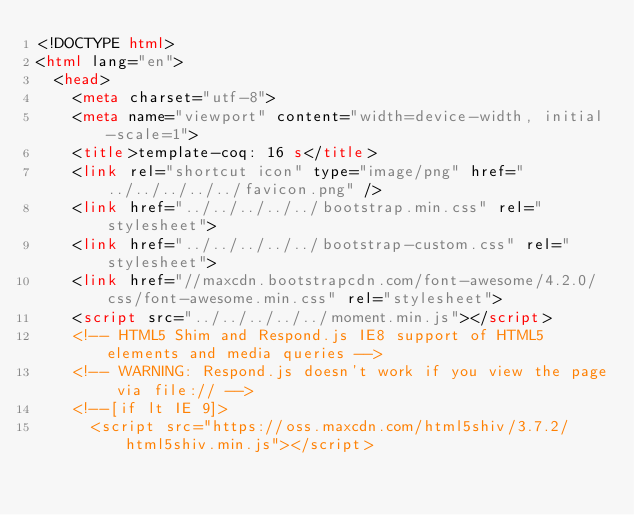Convert code to text. <code><loc_0><loc_0><loc_500><loc_500><_HTML_><!DOCTYPE html>
<html lang="en">
  <head>
    <meta charset="utf-8">
    <meta name="viewport" content="width=device-width, initial-scale=1">
    <title>template-coq: 16 s</title>
    <link rel="shortcut icon" type="image/png" href="../../../../../favicon.png" />
    <link href="../../../../../bootstrap.min.css" rel="stylesheet">
    <link href="../../../../../bootstrap-custom.css" rel="stylesheet">
    <link href="//maxcdn.bootstrapcdn.com/font-awesome/4.2.0/css/font-awesome.min.css" rel="stylesheet">
    <script src="../../../../../moment.min.js"></script>
    <!-- HTML5 Shim and Respond.js IE8 support of HTML5 elements and media queries -->
    <!-- WARNING: Respond.js doesn't work if you view the page via file:// -->
    <!--[if lt IE 9]>
      <script src="https://oss.maxcdn.com/html5shiv/3.7.2/html5shiv.min.js"></script></code> 